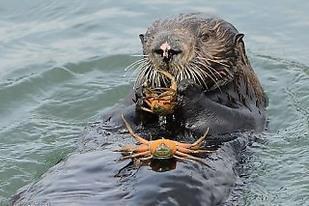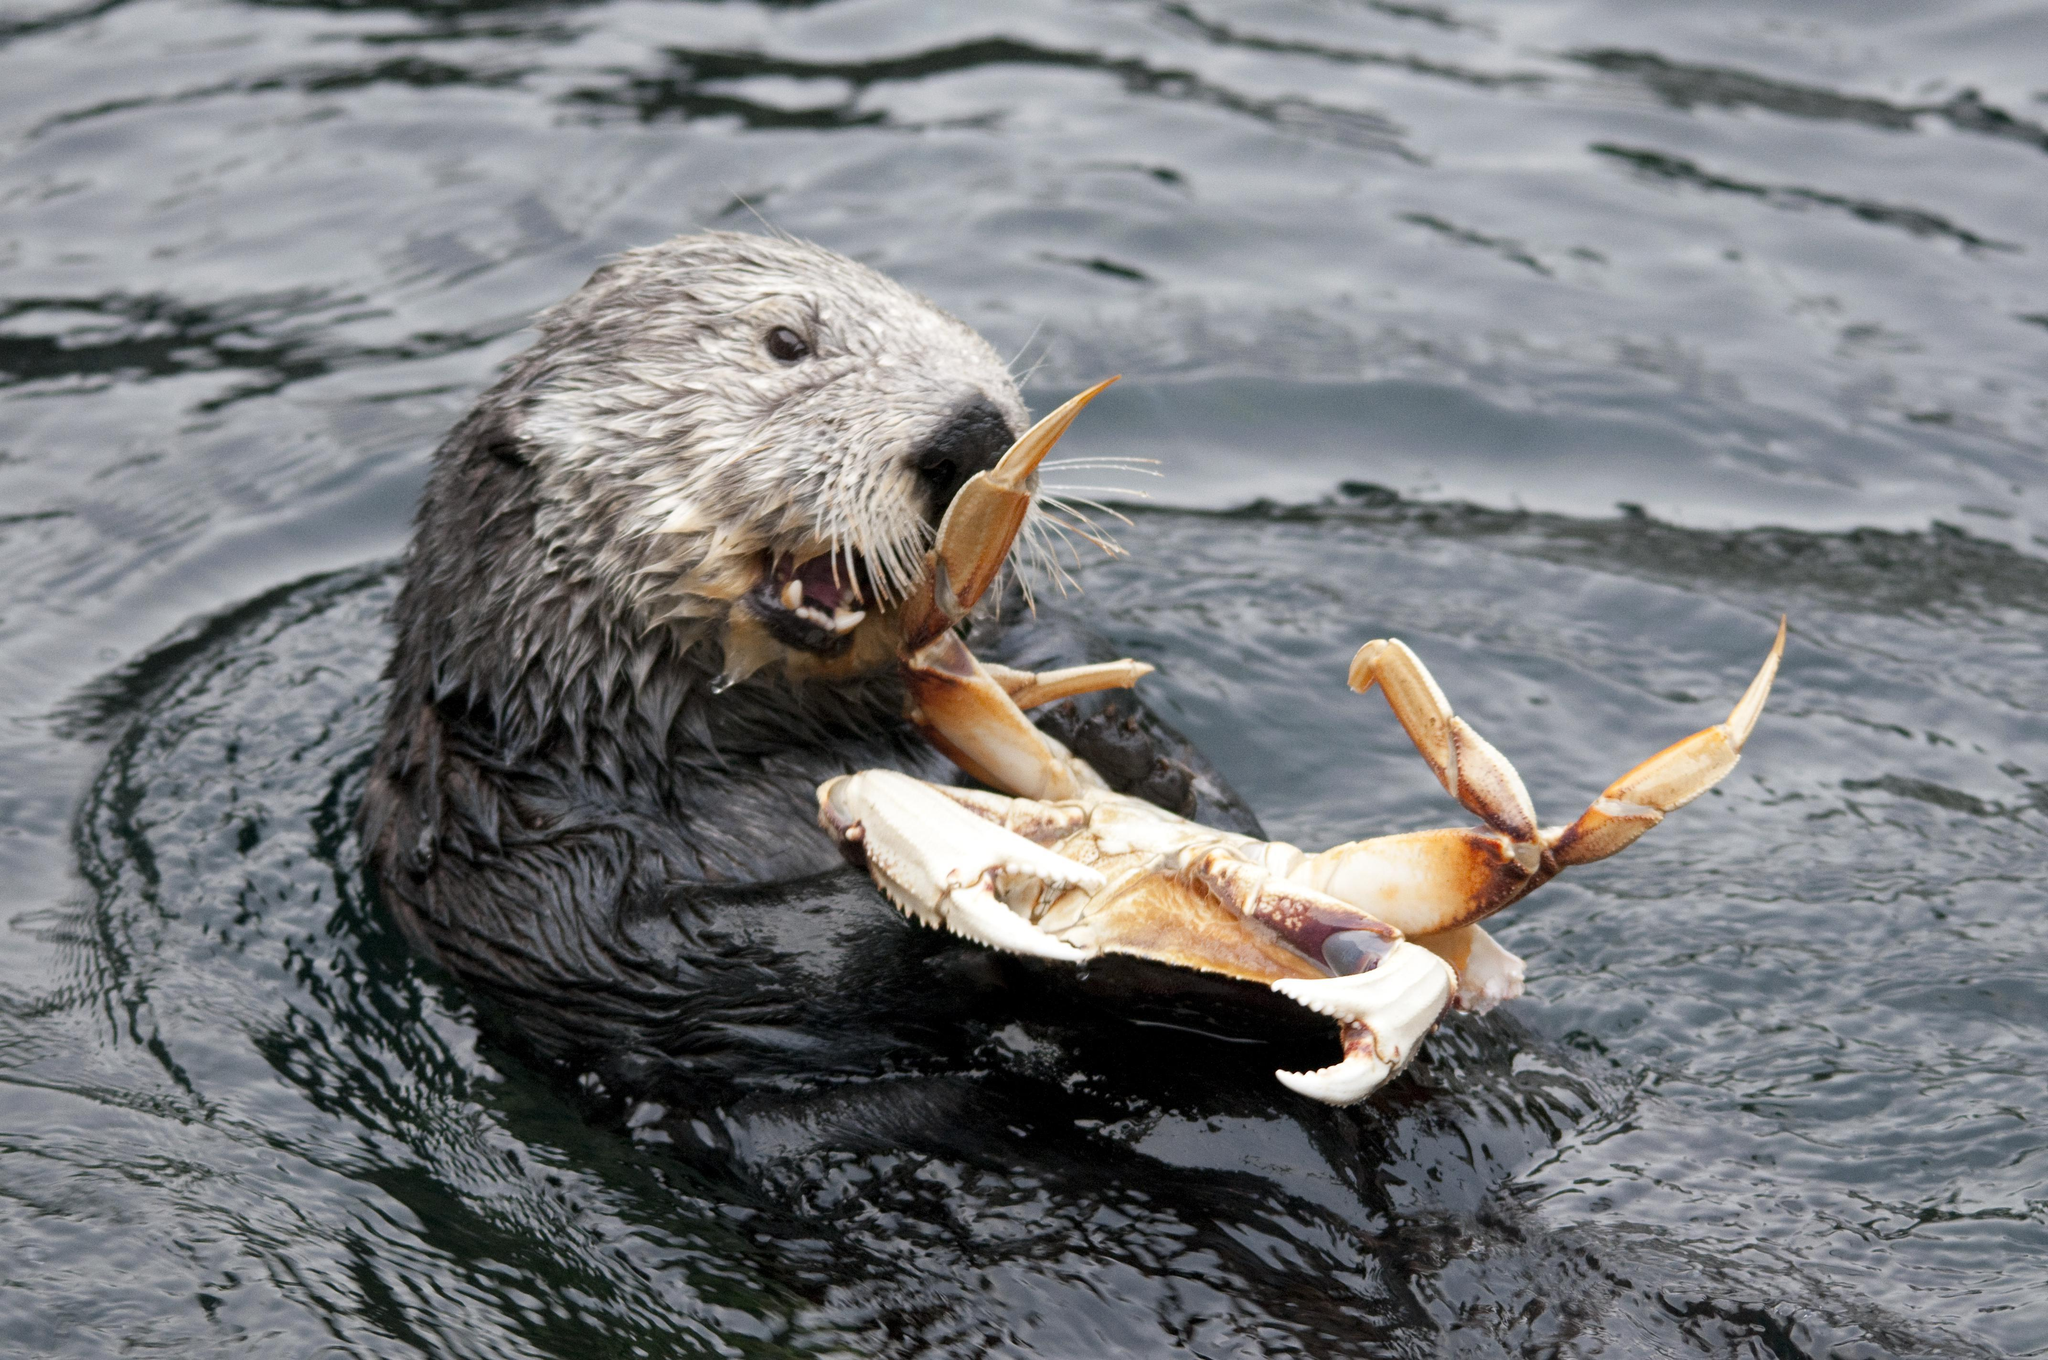The first image is the image on the left, the second image is the image on the right. Examine the images to the left and right. Is the description "In at least one image there is a floating seal with crab in his mouth." accurate? Answer yes or no. Yes. The first image is the image on the left, the second image is the image on the right. Given the left and right images, does the statement "There are two otters which each have a crab in their mouth." hold true? Answer yes or no. Yes. 